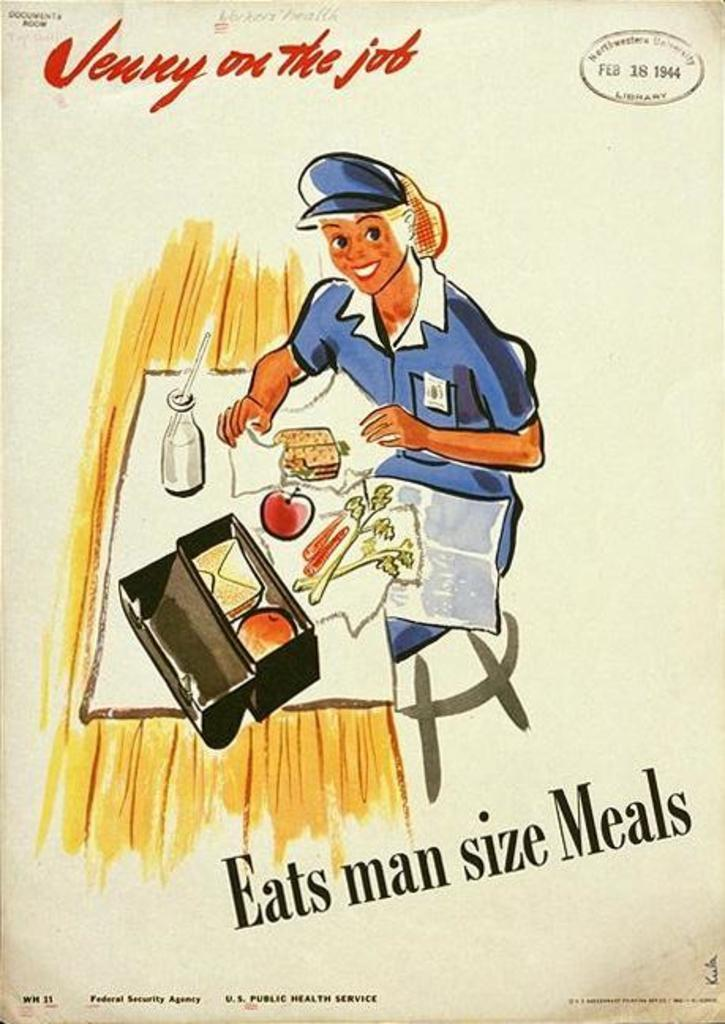Provide a one-sentence caption for the provided image. An poster shows a woman eating a man sized meal. 